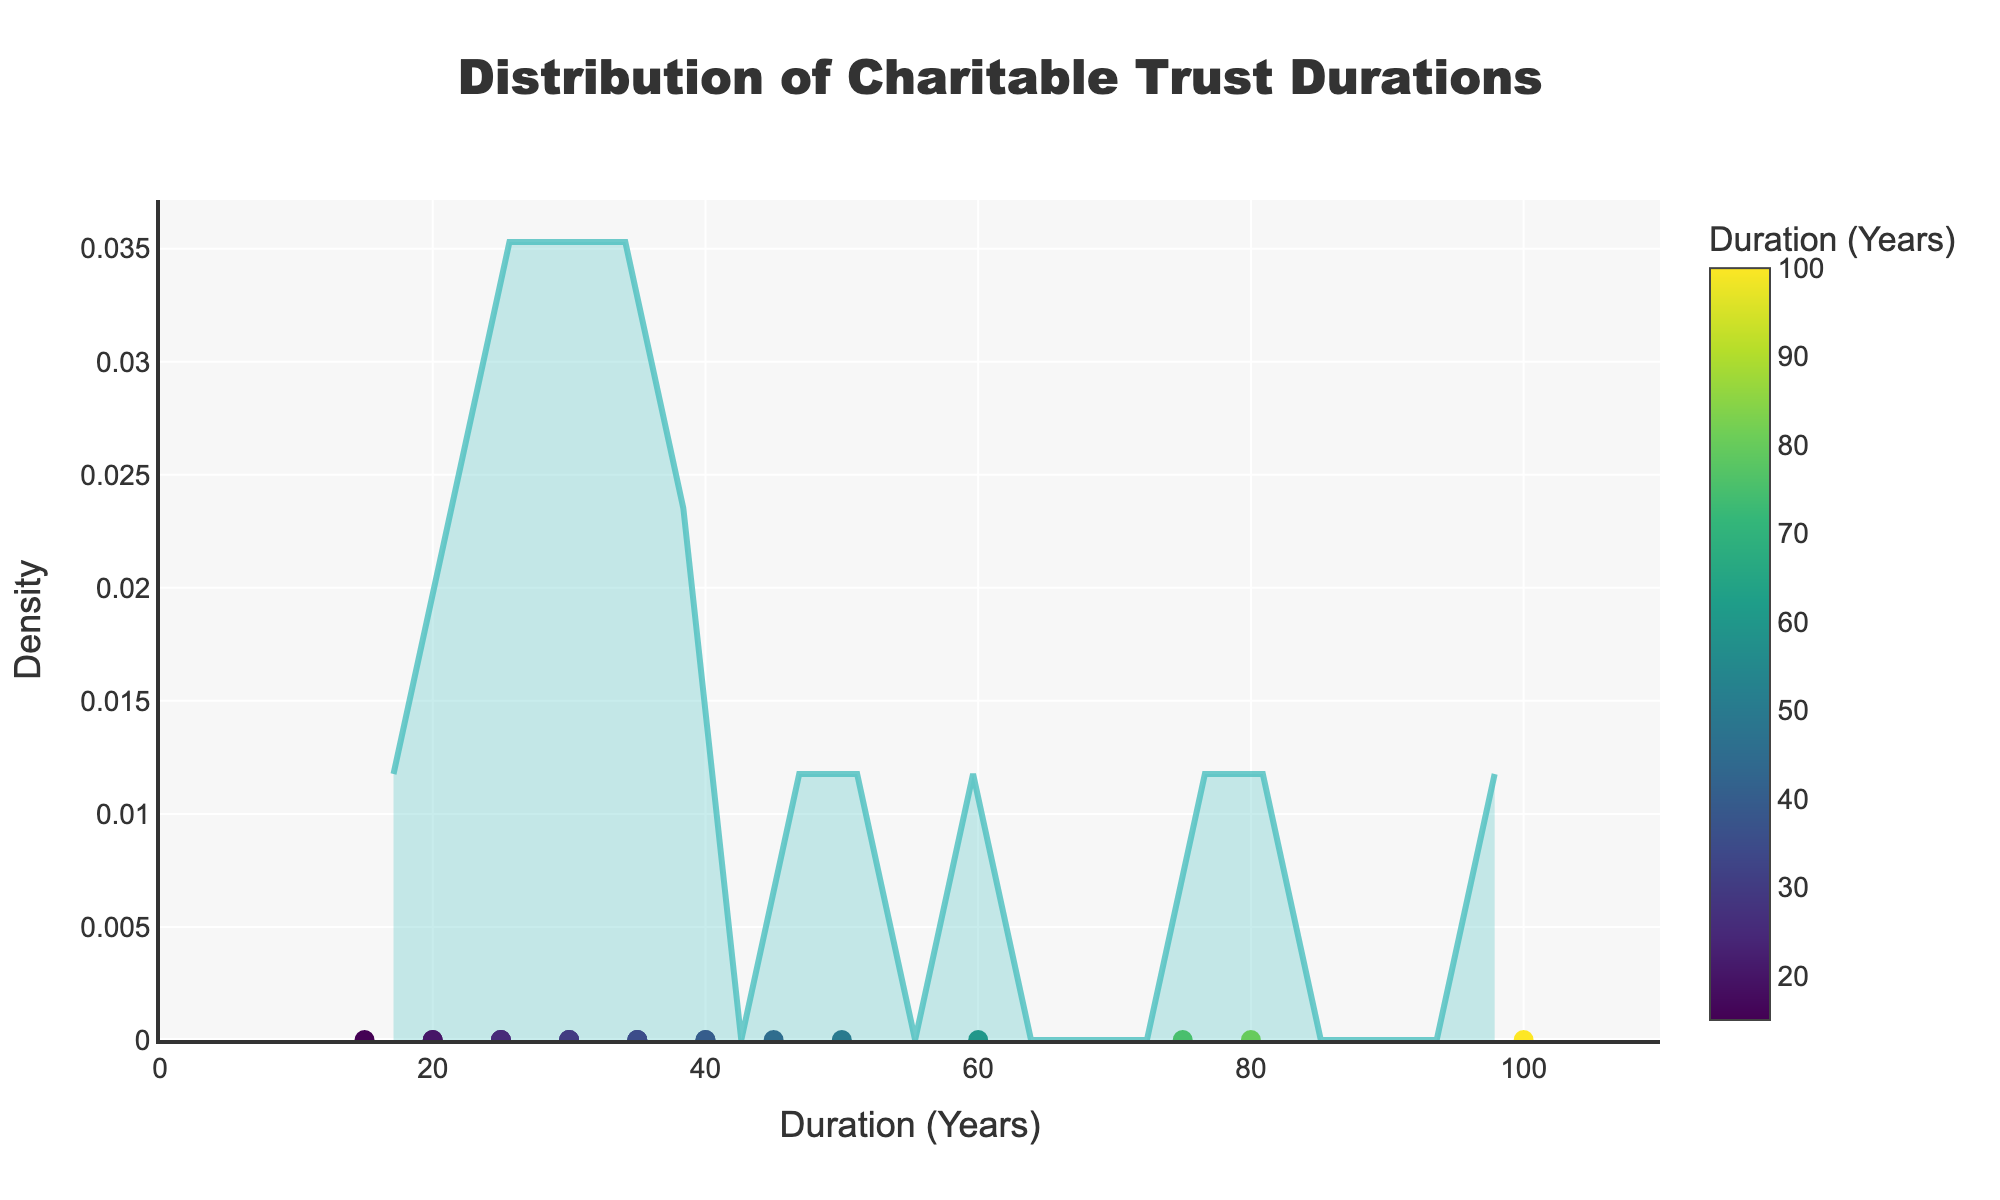What is the title of the figure? The title of the figure can be seen at the top of the plot. In this case, it is clearly stated as "Distribution of Charitable Trust Durations."
Answer: Distribution of Charitable Trust Durations What is the x-axis label on the plot? The label for the x-axis is directly beneath the x-axis line. It indicates what the horizontal axis represents in the figure. Here, it is labeled "Duration (Years)."
Answer: Duration (Years) What trust purpose has the longest duration? Individual data points are marked and hover information shows the trust purpose. The data point with the longest duration is labeled "Religious Institutions" with a duration of 100 years.
Answer: Religious Institutions How many trust purposes have durations of less than 30 years? By counting the individual data points lower than the 30-year mark on the x-axis, we can determine how many trust purposes are below this threshold. There are 6 such purposes (Education Scholarships, Disaster Relief, Child Welfare, Veterans Support, Youth Empowerment, Homelessness Prevention).
Answer: 6 What is the magnitude difference between the shortest and longest trust durations? The shortest duration is 15 years (Disaster Relief), and the longest is 100 years (Religious Institutions). To find the difference, subtract the shortest from the longest: 100 - 15 = 85 years.
Answer: 85 years Which trust purpose is represented by a 60-year duration? Hovering over the data points or looking directly at their labels along the x-axis, we find that "Scientific Advancement" has a 60-year duration.
Answer: Scientific Advancement Which duration range has the highest density of trust purposes on the density plot? Observe the peaks of the density curve to determine where it reaches the highest values. The highest density is around the 30 to 35 years range.
Answer: 30 to 35 years How does the duration of Environmental Conservation compare to that of Disaster Relief? The duration for Environmental Conservation is 75 years, while for Disaster Relief, it is 15 years. By comparing, we see that Environmental Conservation spans a much longer term.
Answer: Environmental Conservation has a longer duration What trust purposes share the same duration of 35 years? By identifying the data points at the 35-year mark, we find that the trust purposes are "Animal Welfare," "Literacy Programs," and "Disability Services."
Answer: Animal Welfare, Literacy Programs, Disability Services What is the median duration of trust purposes in the data set? To find the median, first arrange the durations in ascending order. The middle value or the average of the two middle values in an even-numbered data set is the median. Ordered durations: [15, 20, 20, 25, 25, 25, 30, 30, 30, 35, 35, 35, 40, 40, 45, 50, 60, 75, 80, 100]. There are 20 values, so the median is the average of the 10th and 11th values: (35+35)/2 = 35 years.
Answer: 35 years 